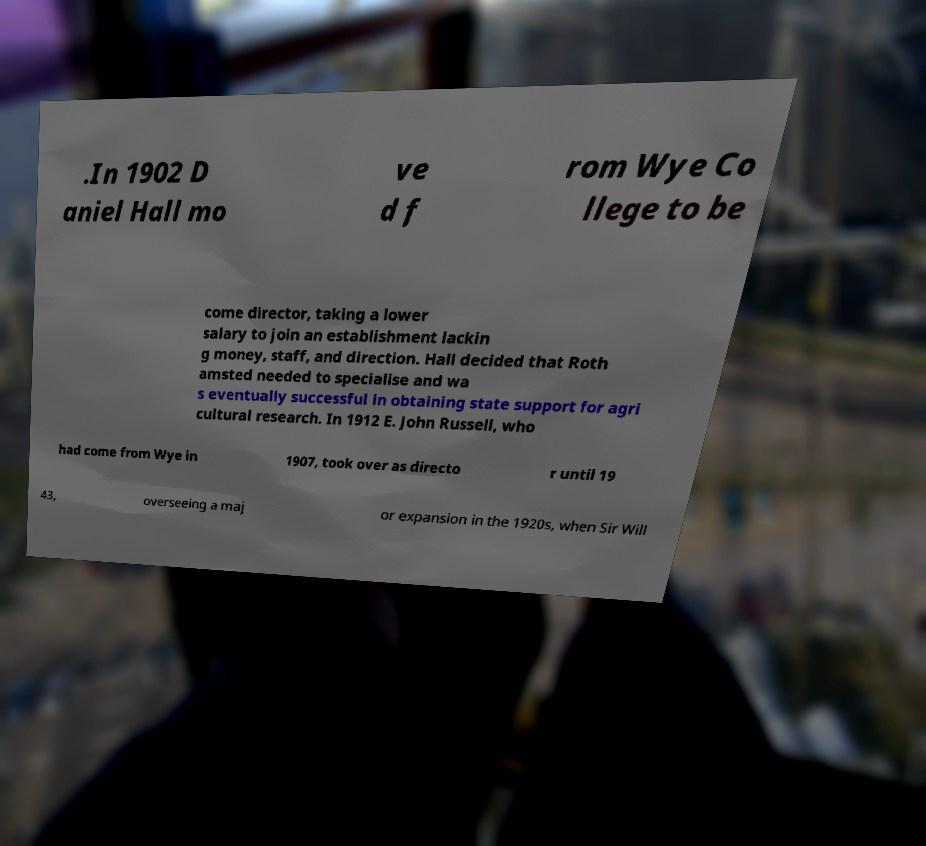What messages or text are displayed in this image? I need them in a readable, typed format. .In 1902 D aniel Hall mo ve d f rom Wye Co llege to be come director, taking a lower salary to join an establishment lackin g money, staff, and direction. Hall decided that Roth amsted needed to specialise and wa s eventually successful in obtaining state support for agri cultural research. In 1912 E. John Russell, who had come from Wye in 1907, took over as directo r until 19 43, overseeing a maj or expansion in the 1920s, when Sir Will 